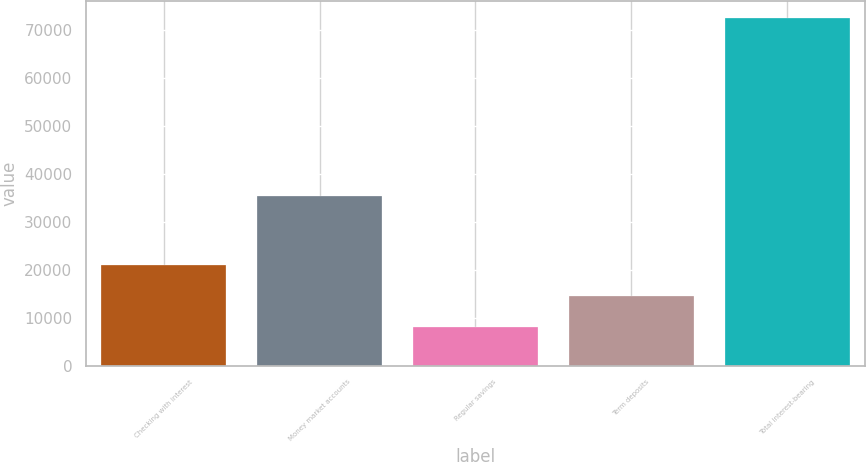Convert chart to OTSL. <chart><loc_0><loc_0><loc_500><loc_500><bar_chart><fcel>Checking with interest<fcel>Money market accounts<fcel>Regular savings<fcel>Term deposits<fcel>Total interest-bearing<nl><fcel>20955.2<fcel>35401<fcel>8057<fcel>14506.1<fcel>72548<nl></chart> 